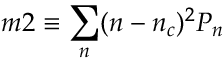<formula> <loc_0><loc_0><loc_500><loc_500>m 2 \equiv \sum _ { n } ( n - n _ { c } ) ^ { 2 } P _ { n }</formula> 